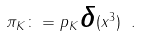<formula> <loc_0><loc_0><loc_500><loc_500>\pi _ { K } \colon = p { _ { K } } { \boldsymbol \delta } ( x ^ { 3 } ) \ .</formula> 